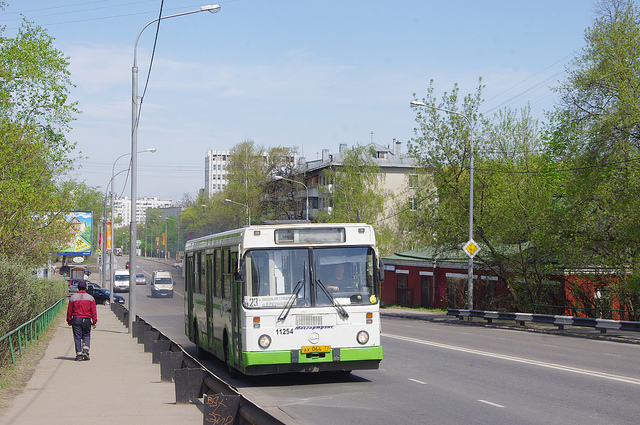<image>How far is the bus stop? I can't tell how far the bus stop is. It may be a block or many feet ahead. How far is the bus stop? I don't know how far the bus stop is. It can be 10 feet, 1/4 mile away, 1 block, or many feet ahead. 